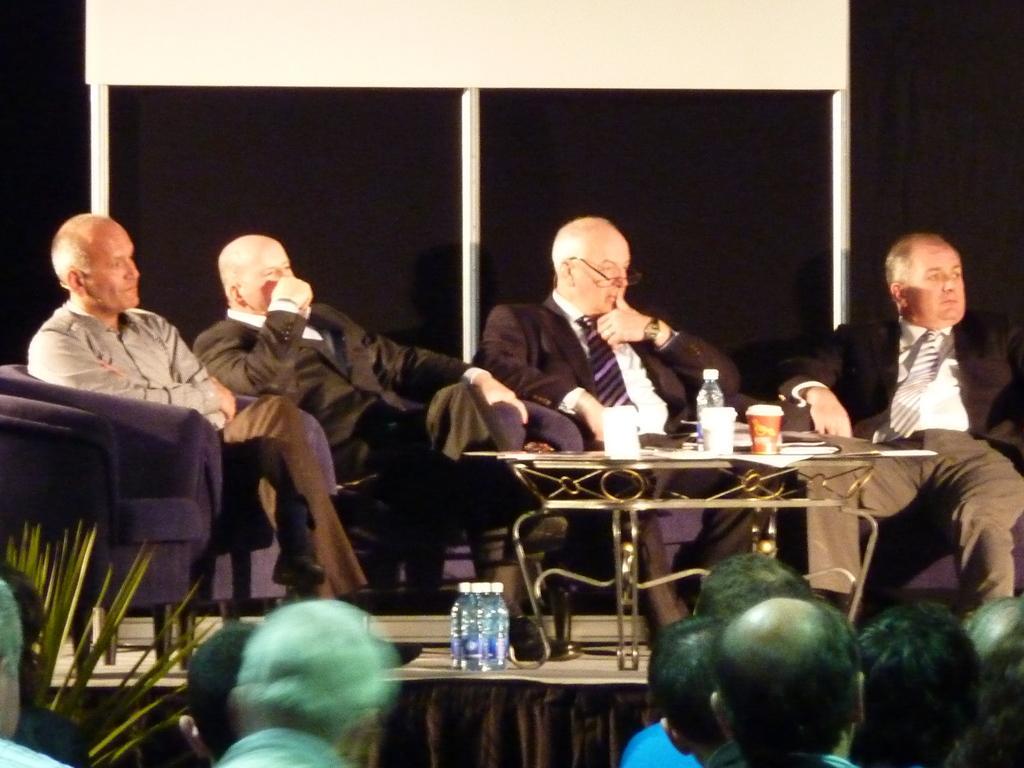Please provide a concise description of this image. In this picture we can see a group of people and in front of them we can see bottles on stage, table with glasses, bottle on it, four men sitting on chairs, cloth, leaves and in the background we can see the wall and some objects. 